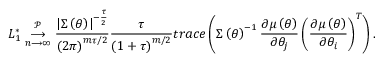<formula> <loc_0><loc_0><loc_500><loc_500>L _ { 1 } ^ { \ast } \underset { n \longrightarrow \infty } { \overset { \mathcal { P } } { \longrightarrow } } \frac { \left | \Sigma \left ( \theta \right ) \right | ^ { - \frac { \tau } { 2 } } } { \left ( 2 \pi \right ) ^ { m \tau / 2 } } \frac { \tau } { \left ( 1 + \tau \right ) ^ { m / 2 } } t r a c e \left ( \Sigma \left ( \theta \right ) ^ { - 1 } \frac { \partial \mu \left ( \theta \right ) } { \partial \theta _ { j } } \left ( \frac { \partial \mu \left ( \theta \right ) } { \partial \theta _ { i } } \right ) ^ { T } \right ) .</formula> 